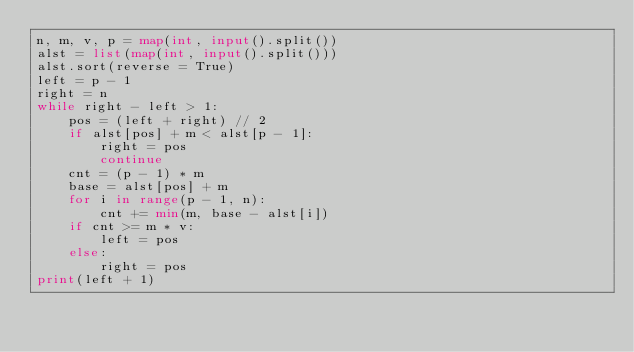<code> <loc_0><loc_0><loc_500><loc_500><_Python_>n, m, v, p = map(int, input().split())
alst = list(map(int, input().split()))
alst.sort(reverse = True)
left = p - 1
right = n
while right - left > 1:
    pos = (left + right) // 2
    if alst[pos] + m < alst[p - 1]:
        right = pos
        continue
    cnt = (p - 1) * m
    base = alst[pos] + m
    for i in range(p - 1, n):
        cnt += min(m, base - alst[i])
    if cnt >= m * v:
        left = pos
    else:
        right = pos
print(left + 1)</code> 